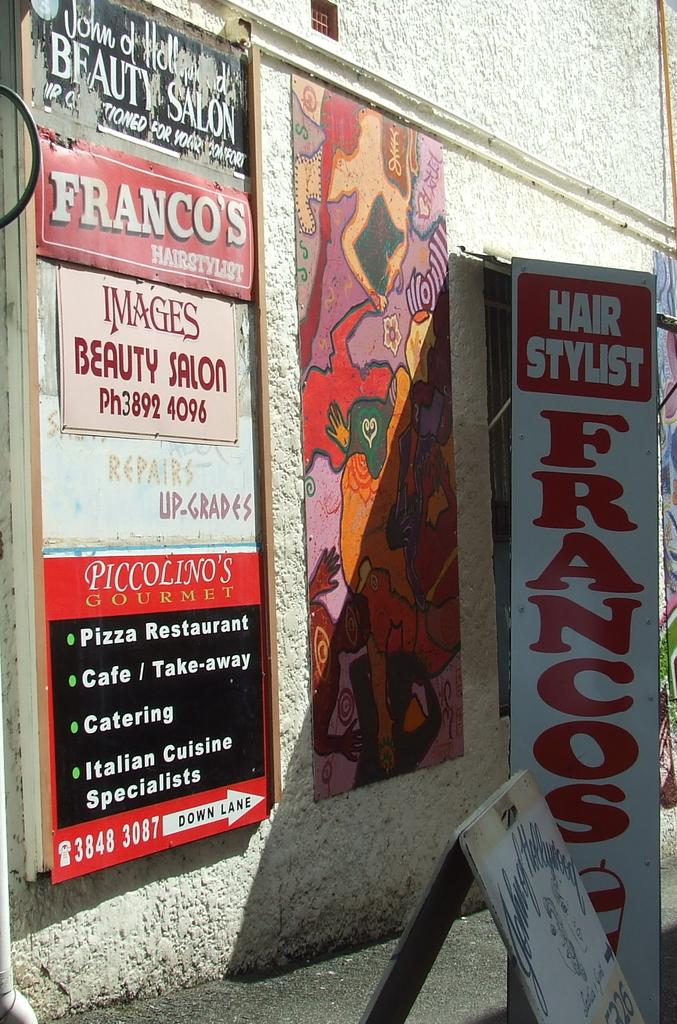<image>
Offer a succinct explanation of the picture presented. Signs on a wall for the hair stylist Francos. 